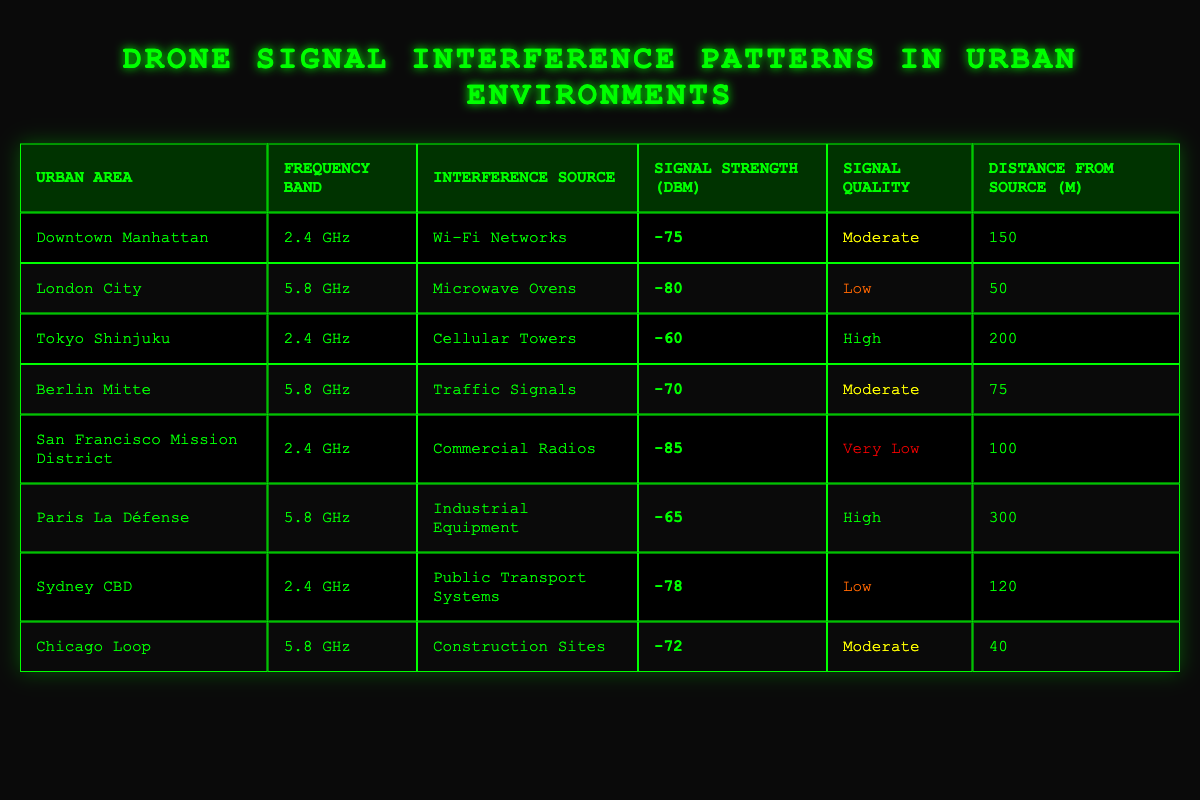What is the signal strength in Downtown Manhattan? The table states that the signal strength in Downtown Manhattan is listed as -75 dBm.
Answer: -75 dBm Which urban area has the lowest signal quality? By checking the signal quality column, San Francisco Mission District is marked as "Very Low," which indicates that it has the lowest signal quality among all listed urban areas.
Answer: San Francisco Mission District What is the distance from the interference source in London City? The table indicates that the distance from the interference source in London City is 50 meters.
Answer: 50 m How many urban areas have a signal strength of -70 dBm or lower? By reviewing the entire table, the urban areas with signal strengths of -70 dBm or lower are London City (-80 dBm), San Francisco Mission District (-85 dBm), and Chicago Loop (-72 dBm). Counting these, there are three areas.
Answer: 3 Is the signal quality in Paris La Défense high? The table shows that the signal quality for Paris La Défense is categorized as "High," thus confirming this fact.
Answer: Yes What is the average distance from the interference source of all urban areas listed? To find the average distance, sum the distances: 150 + 50 + 200 + 75 + 100 + 300 + 120 + 40 = 1035. Then divide by the number of urban areas, which is 8. The average distance is 1035 / 8 = 129.375 m.
Answer: 129.375 m Which interference source is associated with a signal strength of -60 dBm? Looking at the table, the source associated with a signal strength of -60 dBm is "Cellular Towers" in the urban area of Tokyo Shinjuku.
Answer: Cellular Towers What is the highest signal strength among the urban areas listed? By examining the signal strengths in the table, the highest signal strength is found in Tokyo Shinjuku with -60 dBm.
Answer: -60 dBm 